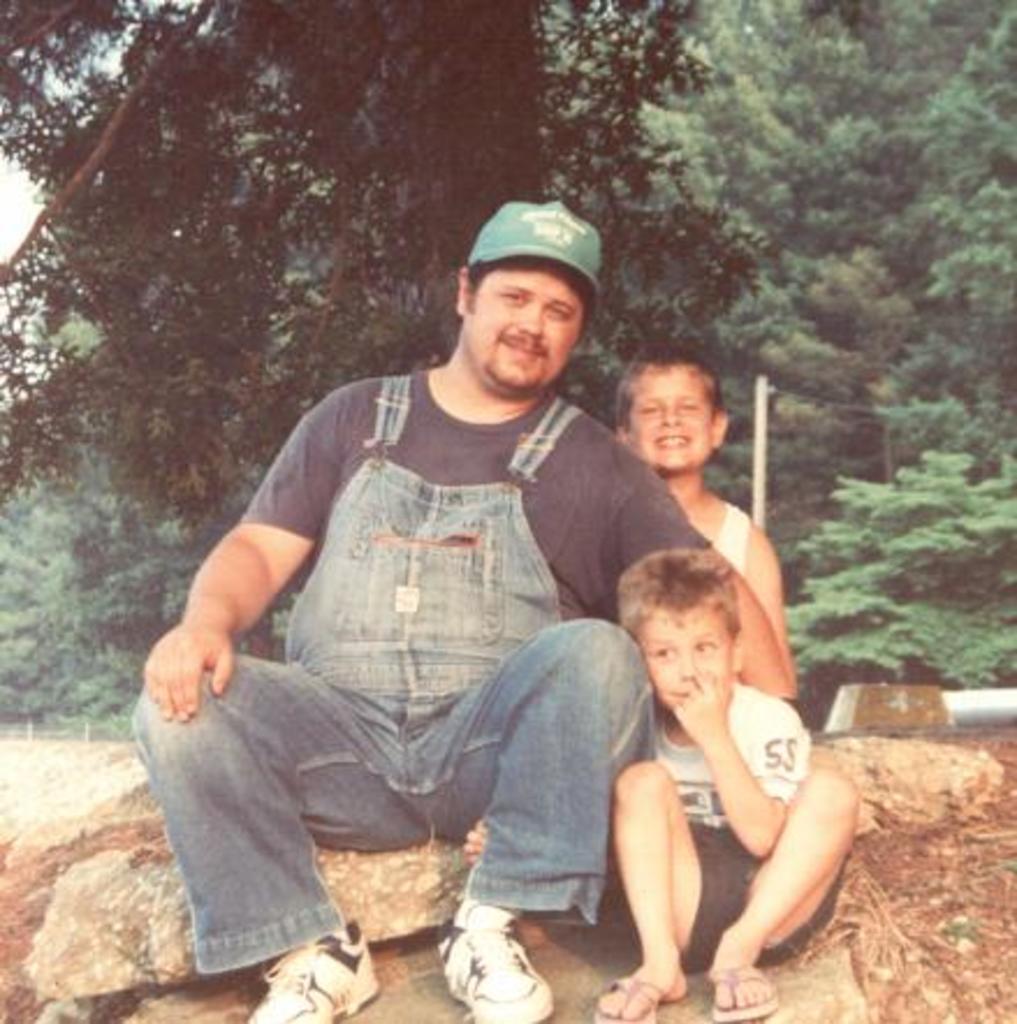Could you give a brief overview of what you see in this image? In this image I can see 3 people sitting on the rocks. There are trees at the back. 